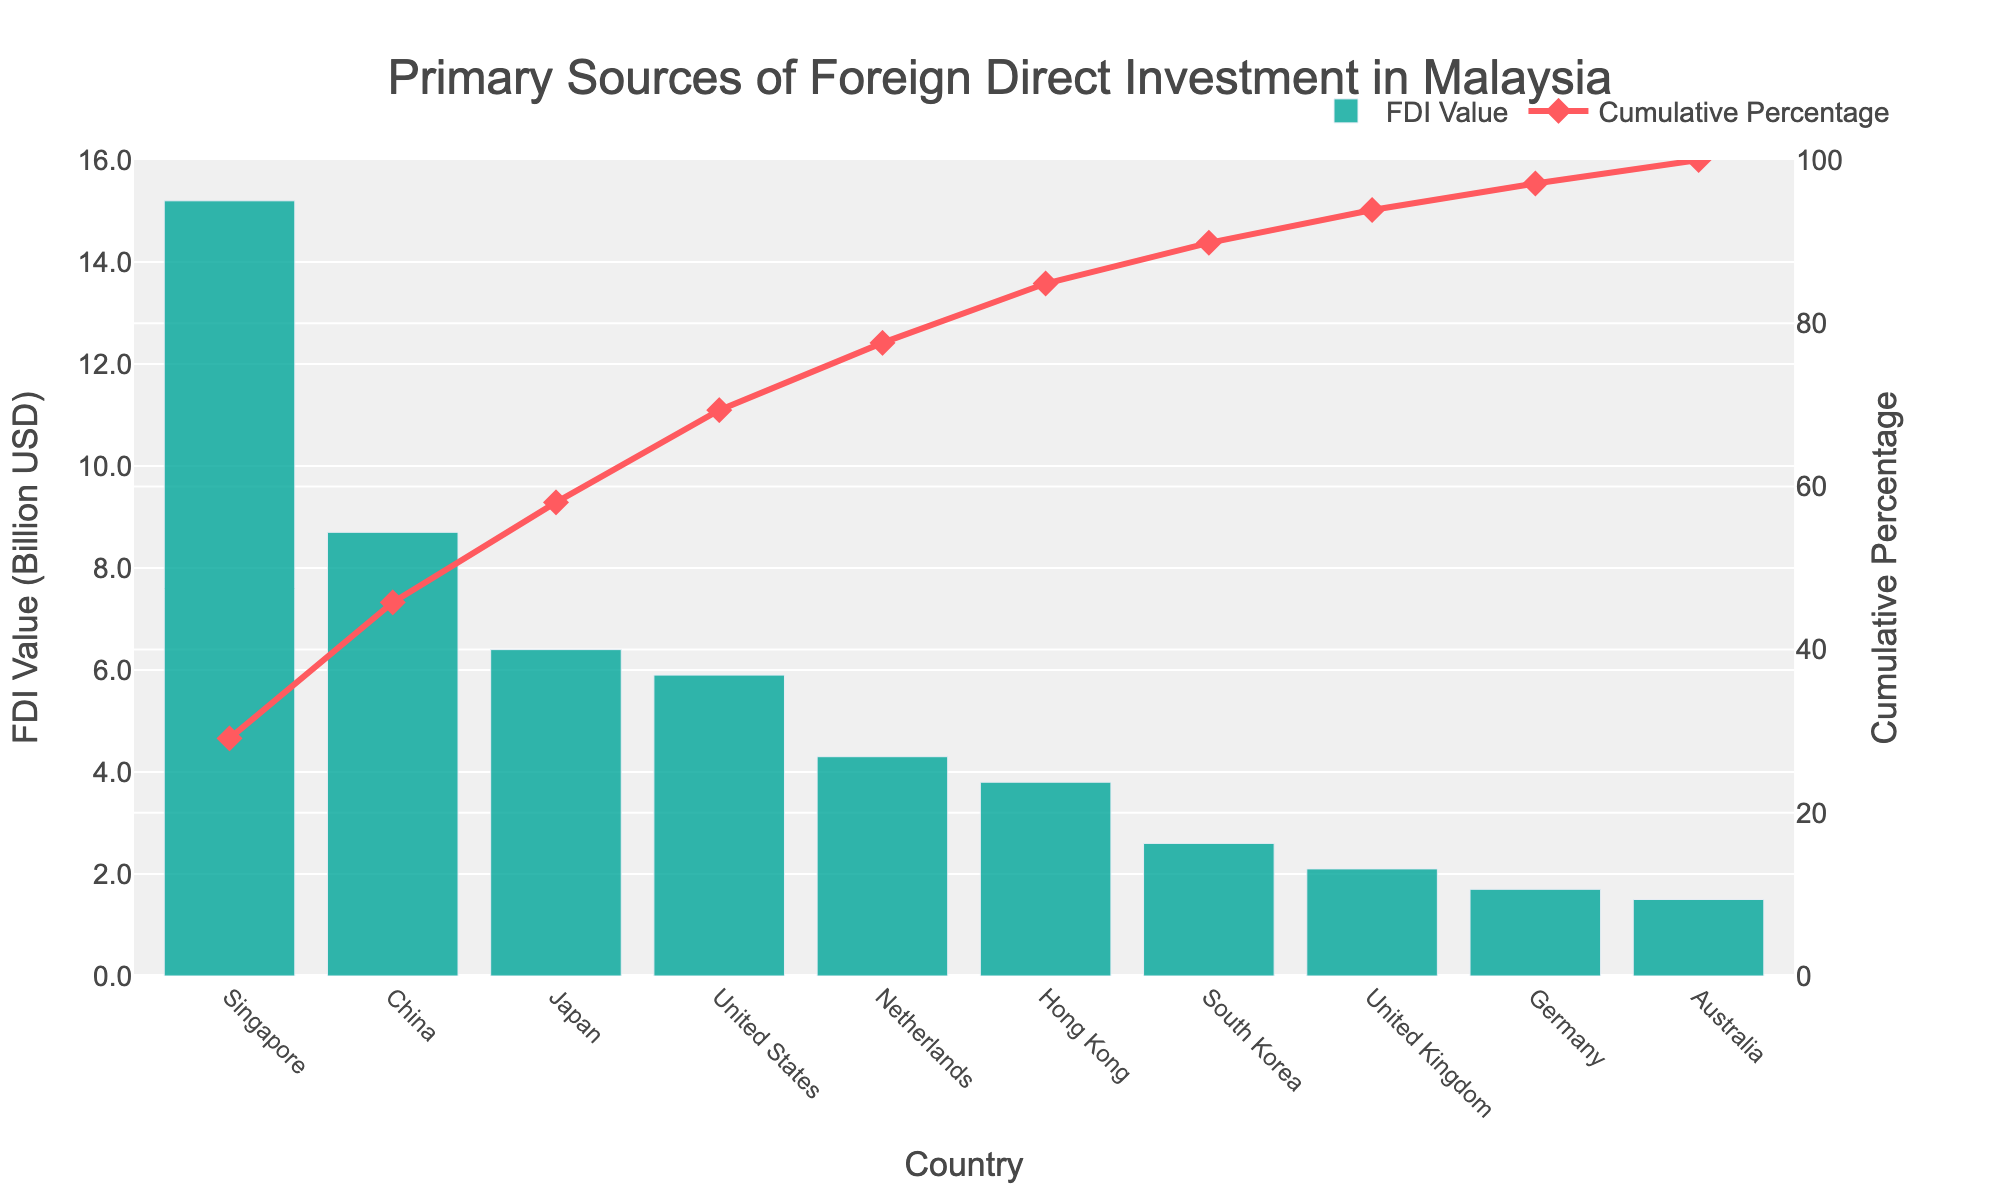What's the title of the chart? The title is displayed at the top of the chart. The text reads "Primary Sources of Foreign Direct Investment in Malaysia".
Answer: Primary Sources of Foreign Direct Investment in Malaysia Which country has the highest FDI value? The bar chart shows the FDI values for each country. The highest bar represents Singapore with an FDI value of 15.2 billion USD.
Answer: Singapore What is the cumulative percentage for China? To find the cumulative percentage for China, refer to the line chart. The cumulative percentage for China is shown as the second point on the line, at approximately 37.4%.
Answer: Approximately 37.4% How many countries are represented in the chart? Count the number of bars on the chart, each representing a different country. There are 10 bars in total.
Answer: 10 Which country has the lowest FDI value? The shortest bar on the bar chart indicates the country with the lowest FDI value. That country is Australia with an FDI value of 1.5 billion USD.
Answer: Australia What is the combined FDI value from Japan and the United States? To find the combined FDI value, add the values for Japan (6.4 billion USD) and the United States (5.9 billion USD). 6.4 + 5.9 = 12.3 billion USD.
Answer: 12.3 billion USD Which countries have an FDI value lower than 3 billion USD? Look for bars whose value is less than 3 billion USD. These countries are South Korea, United Kingdom, Germany, and Australia.
Answer: South Korea, United Kingdom, Germany, Australia What is the cumulative percentage at the last country on the list? The last point on the cumulative percentage line represents the cumulative percentage. For Australia, it is 100%.
Answer: 100% What is the difference in FDI value between the Netherlands and Hong Kong? Subtract Hong Kong's FDI value (3.8 billion USD) from the Netherlands' FDI value (4.3 billion USD). 4.3 - 3.8 = 0.5 billion USD.
Answer: 0.5 billion USD Which country is the fifth largest source of FDI in Malaysia? The fifth largest bar in descending order is the Netherlands, with an FDI value of 4.3 billion USD.
Answer: Netherlands 